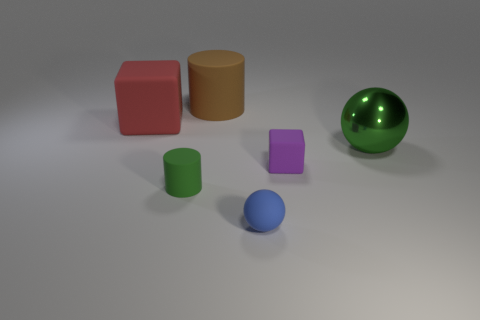Subtract 1 balls. How many balls are left? 1 Add 4 rubber cylinders. How many objects exist? 10 Subtract all large brown metallic cylinders. Subtract all tiny blue matte objects. How many objects are left? 5 Add 1 purple objects. How many purple objects are left? 2 Add 6 gray metal spheres. How many gray metal spheres exist? 6 Subtract 0 blue cylinders. How many objects are left? 6 Subtract all spheres. How many objects are left? 4 Subtract all brown spheres. Subtract all green cylinders. How many spheres are left? 2 Subtract all gray blocks. How many gray balls are left? 0 